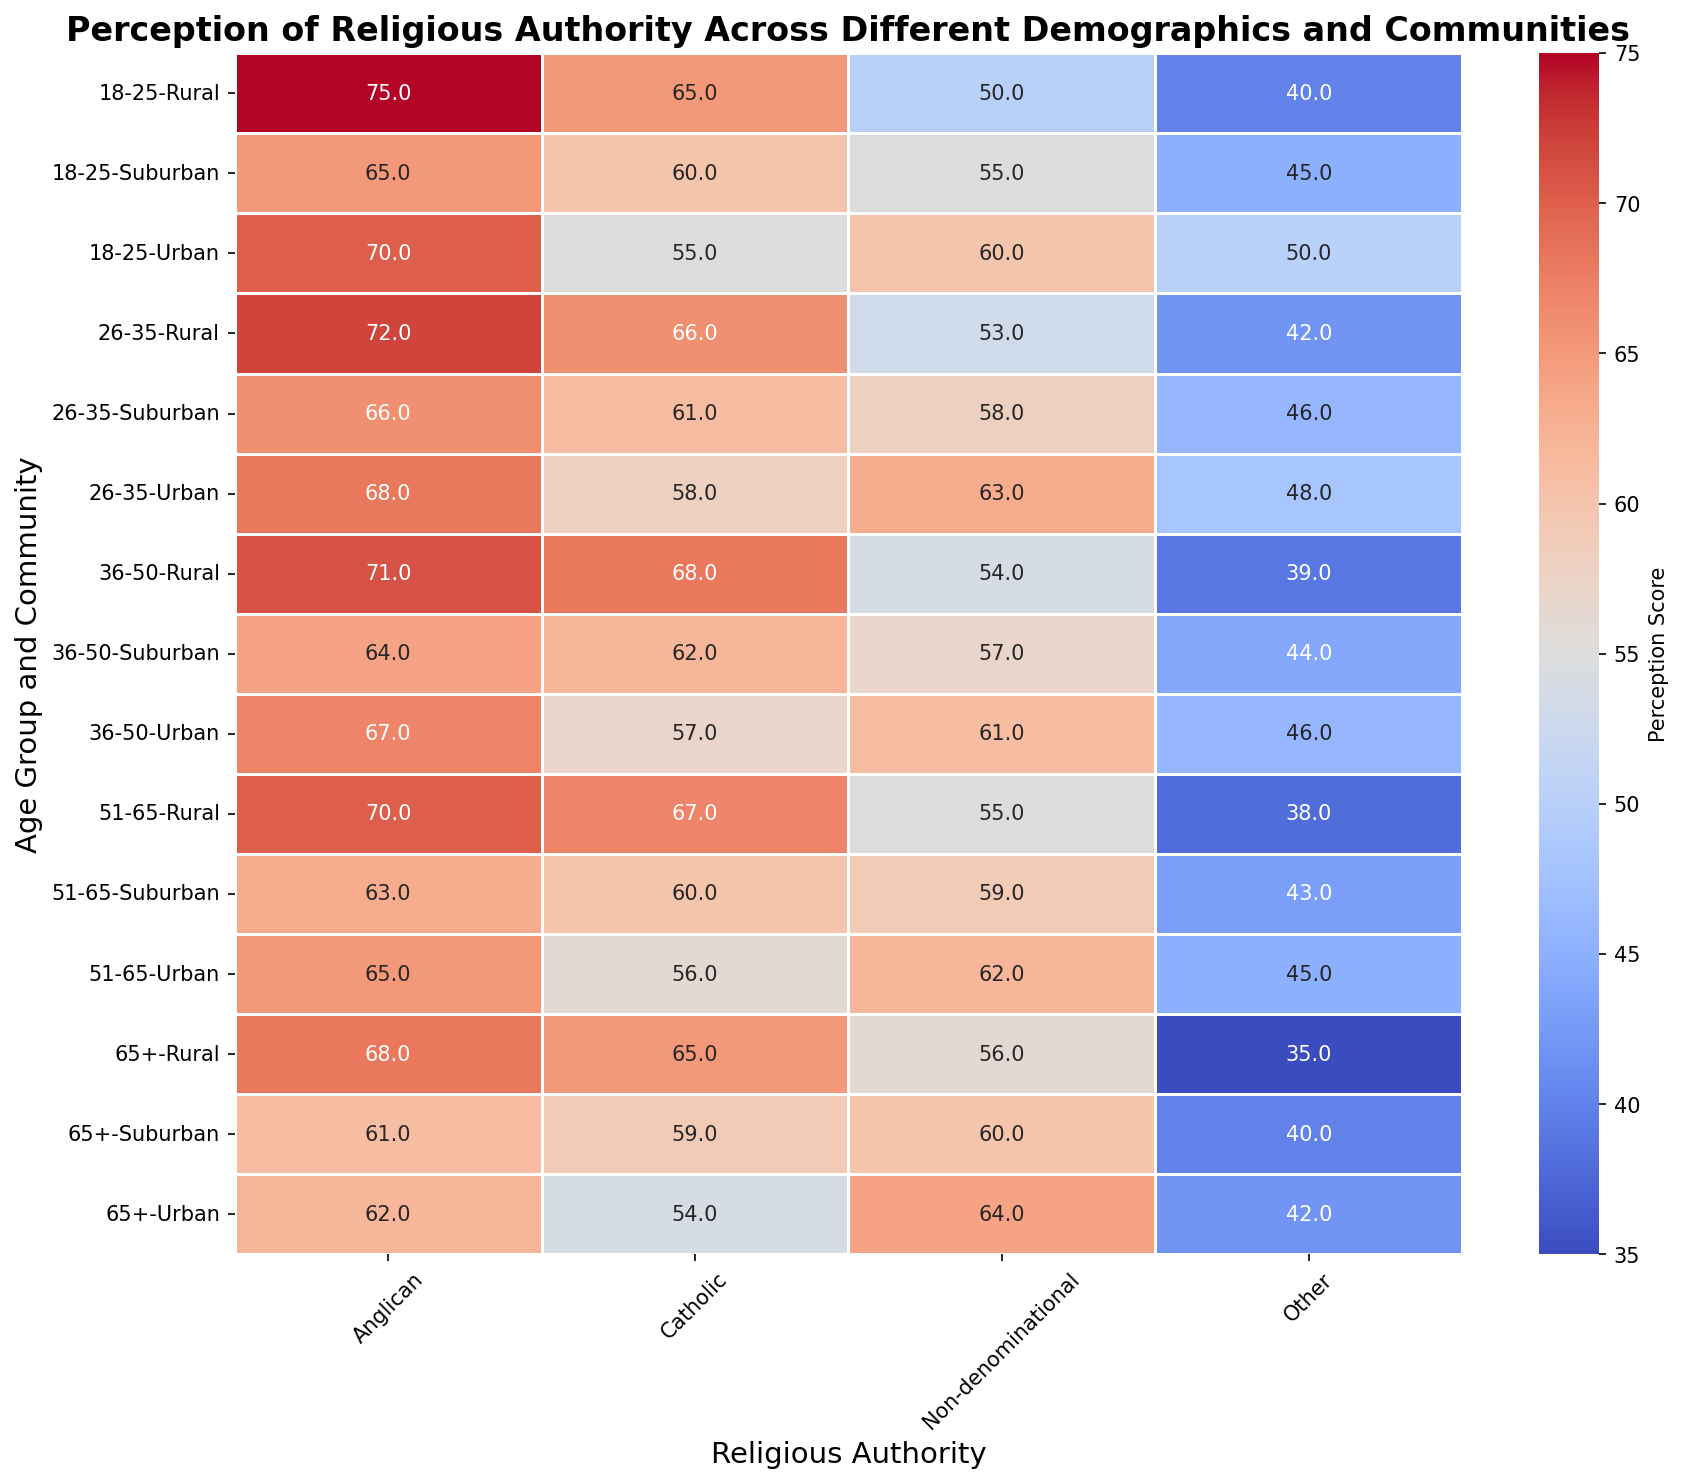What is the perception score for Anglican authority among the 18-25 age group in rural communities? Locate the cell where the age group is 18-25, community is rural, and religious authority is Anglican, the perception score shown is 75.
Answer: 75 How does the perception score of Catholic authority in suburban communities compare between the 26-35 age group and the 51-65 age group? Compare the perception scores of Catholic authority for suburban communities between the 26-35 age group (61) and the 51-65 age group (60), which shows a slight decrease.
Answer: 61 vs 60 Which community has the highest perception score for Anglican authority among the 36-50 age group? Identify the cells for the 36-50 age group across different communities and check Anglican scores; highest score is 71 in rural communities.
Answer: Rural What is the difference in perception scores for Non-denominational authority between the oldest (65+) and youngest (18-25) age groups in urban communities? Locate the cells for Non-denominational authority in urban communities for both age groups: 65+ (64) and 18-25 (60). The difference is 64 - 60 = 4.
Answer: 4 What is the overall trend in perception scores for Catholic authority across all age groups in rural communities? Check the perception scores for Catholic authority in rural communities: 18-25 (65), 26-35 (66), 36-50 (68), 51-65 (67), and 65+ (65). The trend slightly increases, peaks in 36-50, and then declines.
Answer: Slightly increasing, peaking at 36-50 What's the average perception score for Anglican religious authority across all age groups in suburban communities? Sum the Anglican perception scores in suburban communities: 18-25 (65), 26-35 (66), 36-50 (64), 51-65 (63), 65+ (61). Calculate average: (65 + 66 + 64 + 63 + 61) / 5 = 63.8.
Answer: 63.8 How does the perception score for "Other" authority among the 26-35 age group in rural communities compare to the perception score for Anglican authority in the same category? Compare the perception score for Other authority (42) with Anglican authority (72) within the rural communities in the 26-35 age group. The Anglican score is significantly higher.
Answer: Anglican is higher Which age group in urban communities has the lowest perception score for 'Other' religious authority? Identify the lowest perception score for 'Other' authority across age groups in urban communities. 65+ age group has the lowest score (42).
Answer: 65+ What are the visual differences in perception scores for Non-denominational authority between urban and rural communities in the 51-65 age group as depicted in the heatmap? Observe the color gradient and numerical values for Non-denominational authority in urban (62) and rural (55) areas for age group 51-65. Urban areas show a higher score with more intense color.
Answer: Urban higher, more intense Which age group and community combination has the lowest perception score for any religious authority? Identify the lowest perception score across all cells in the heatmap, which is 35 for 'Other' authority in '65+' age group in rural communities.
Answer: 'Other' in '65+' rural 